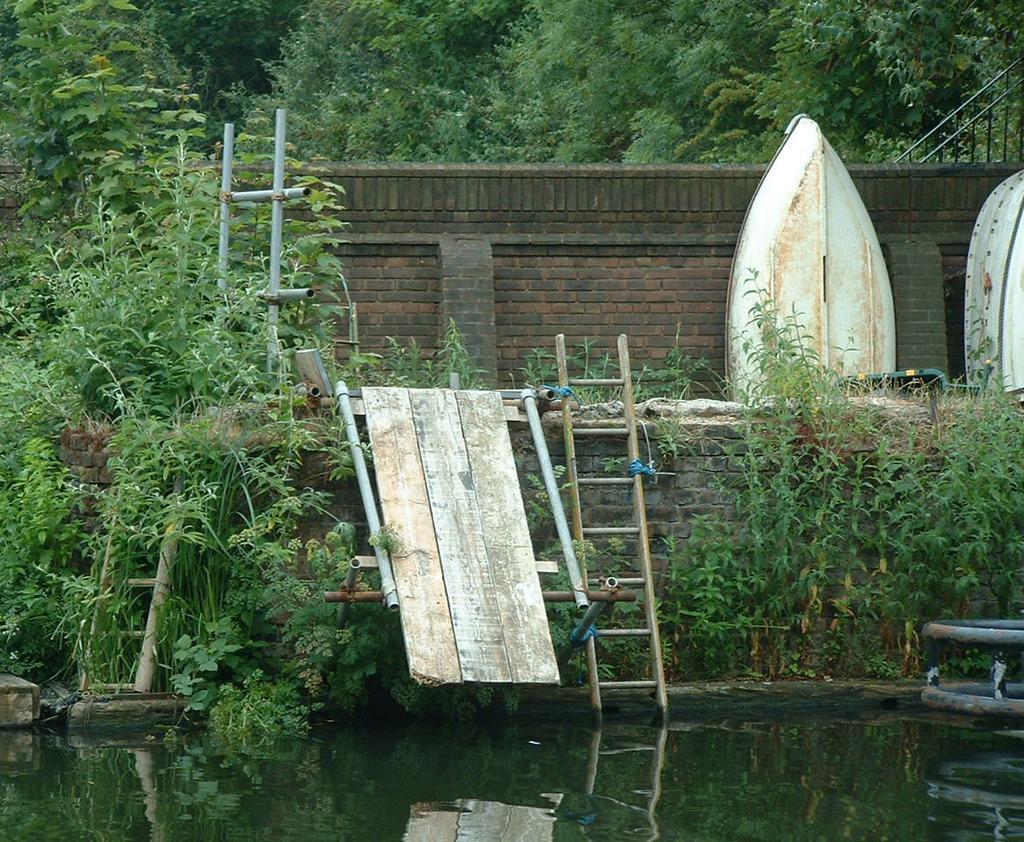How would you summarize this image in a sentence or two? This is water. Here we can see plants and ladders. In the background there is a wall and trees. 